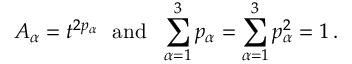<formula> <loc_0><loc_0><loc_500><loc_500>A _ { \alpha } = t ^ { 2 p _ { \alpha } } a n d \sum _ { \alpha = 1 } ^ { 3 } p _ { \alpha } = \sum _ { \alpha = 1 } ^ { 3 } p _ { \alpha } ^ { 2 } = 1 \, .</formula> 